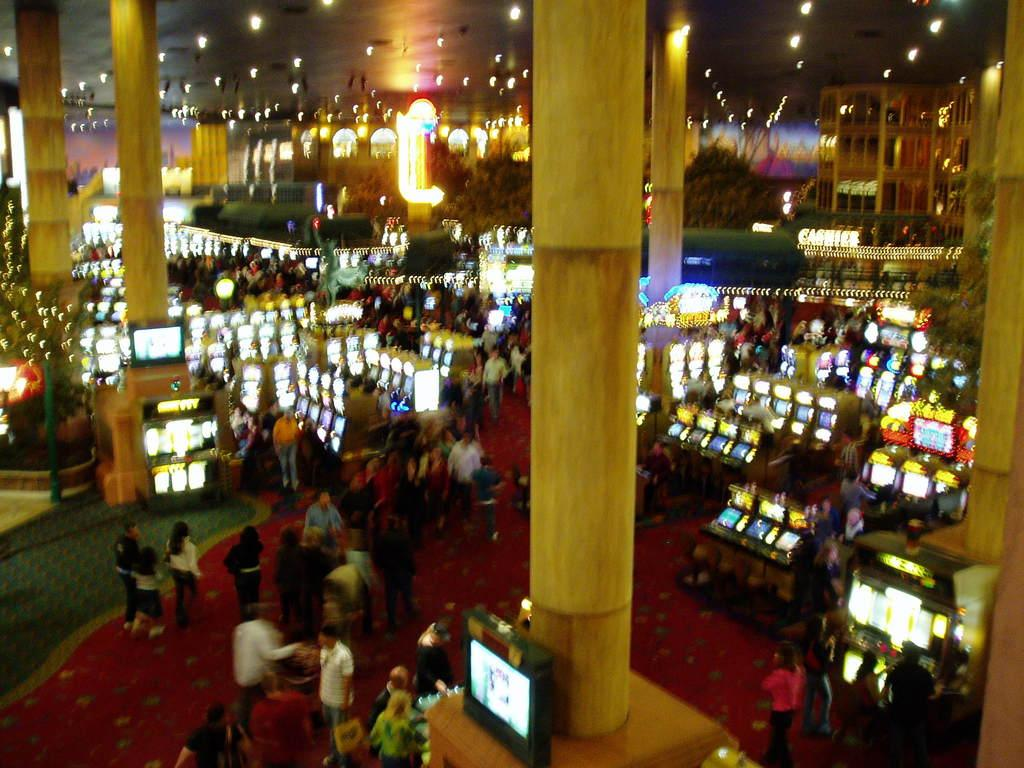What type of machines can be seen in the image? There are gaming machines in the image. What are the people in the image doing? The people in the image are walking on a mat. What type of electronic devices are present in the image? There are televisions in the image. What architectural features can be seen in the image? There are pillars in the image. What can be seen in the background of the image? There are buildings and lights in the background of the image. What type of yarn is being used by the people walking on the mat in the image? There is no yarn present in the image; the people are walking on a mat. What type of pain is being experienced by the gaming machines in the image? There is no indication of pain in the image, as the subject is gaming machines. 